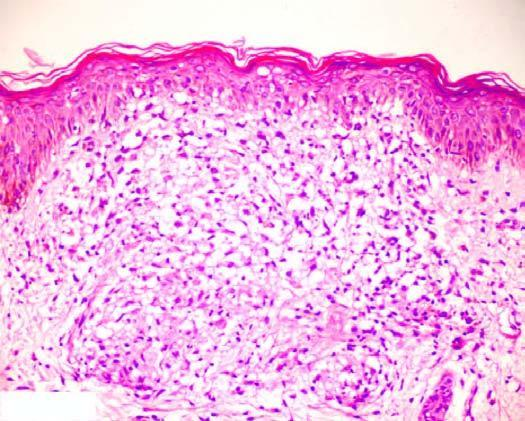s the granuloma composed of epithelioid cells with sparse langhans ' giant cells and lymphocytes?
Answer the question using a single word or phrase. Yes 